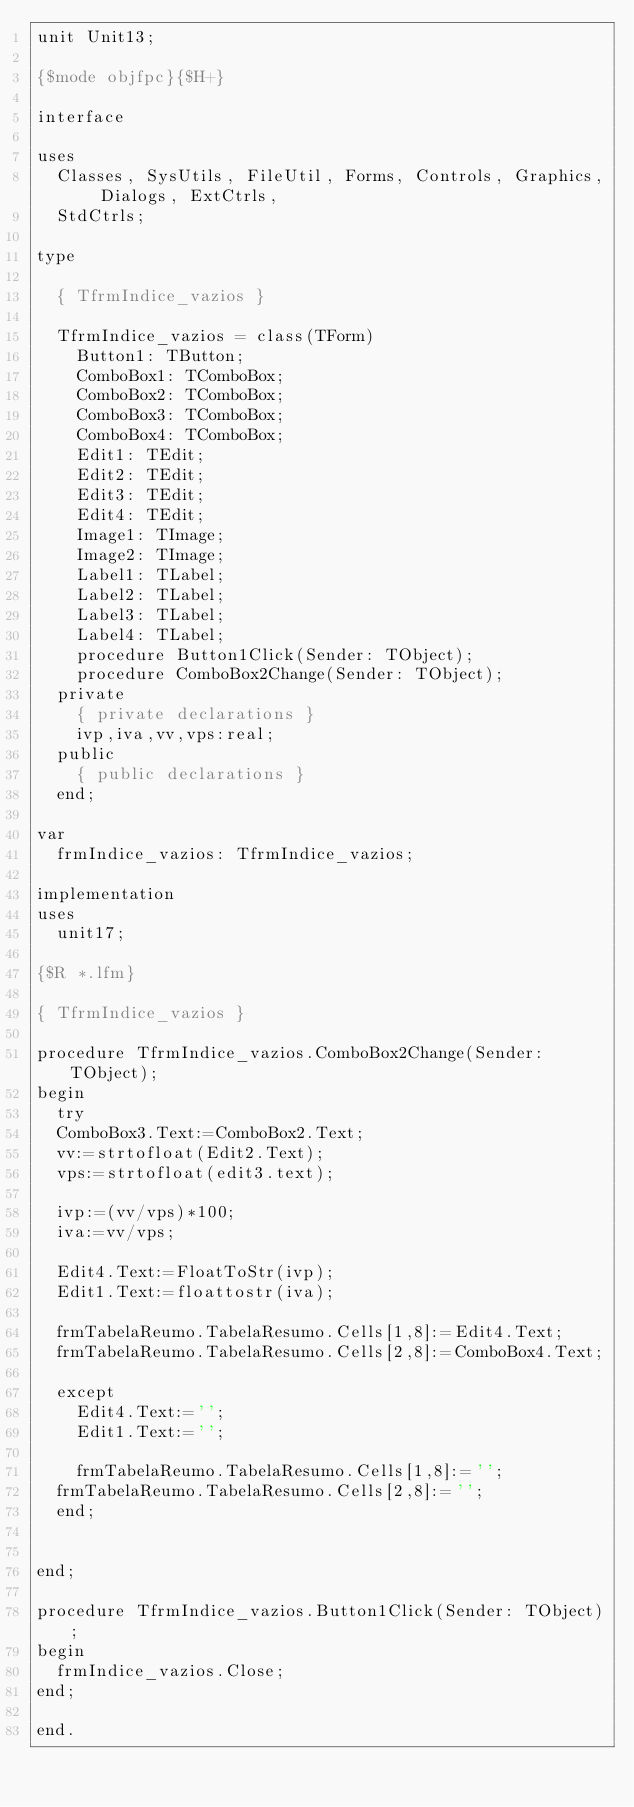Convert code to text. <code><loc_0><loc_0><loc_500><loc_500><_Pascal_>unit Unit13;

{$mode objfpc}{$H+}

interface

uses
  Classes, SysUtils, FileUtil, Forms, Controls, Graphics, Dialogs, ExtCtrls,
  StdCtrls;

type

  { TfrmIndice_vazios }

  TfrmIndice_vazios = class(TForm)
    Button1: TButton;
    ComboBox1: TComboBox;
    ComboBox2: TComboBox;
    ComboBox3: TComboBox;
    ComboBox4: TComboBox;
    Edit1: TEdit;
    Edit2: TEdit;
    Edit3: TEdit;
    Edit4: TEdit;
    Image1: TImage;
    Image2: TImage;
    Label1: TLabel;
    Label2: TLabel;
    Label3: TLabel;
    Label4: TLabel;
    procedure Button1Click(Sender: TObject);
    procedure ComboBox2Change(Sender: TObject);
  private
    { private declarations }
    ivp,iva,vv,vps:real;
  public
    { public declarations }
  end;

var
  frmIndice_vazios: TfrmIndice_vazios;

implementation
uses
  unit17;

{$R *.lfm}

{ TfrmIndice_vazios }

procedure TfrmIndice_vazios.ComboBox2Change(Sender: TObject);
begin
  try
  ComboBox3.Text:=ComboBox2.Text;
  vv:=strtofloat(Edit2.Text);
  vps:=strtofloat(edit3.text);

  ivp:=(vv/vps)*100;
  iva:=vv/vps;

  Edit4.Text:=FloatToStr(ivp);
  Edit1.Text:=floattostr(iva);

  frmTabelaReumo.TabelaResumo.Cells[1,8]:=Edit4.Text;
  frmTabelaReumo.TabelaResumo.Cells[2,8]:=ComboBox4.Text;

  except
    Edit4.Text:='';
    Edit1.Text:='';

    frmTabelaReumo.TabelaResumo.Cells[1,8]:='';
  frmTabelaReumo.TabelaResumo.Cells[2,8]:='';
  end;


end;

procedure TfrmIndice_vazios.Button1Click(Sender: TObject);
begin
  frmIndice_vazios.Close;
end;

end.

</code> 